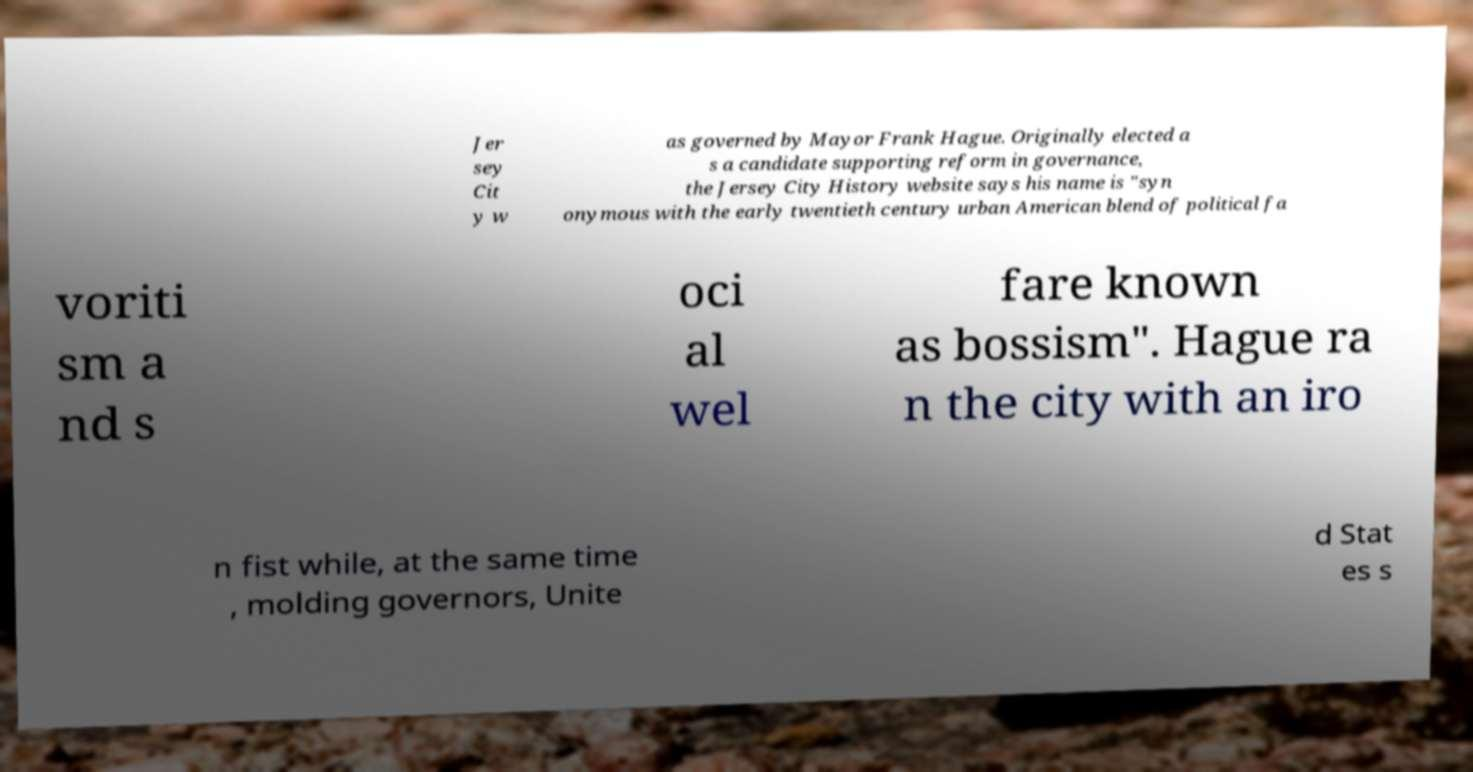Could you extract and type out the text from this image? Jer sey Cit y w as governed by Mayor Frank Hague. Originally elected a s a candidate supporting reform in governance, the Jersey City History website says his name is "syn onymous with the early twentieth century urban American blend of political fa voriti sm a nd s oci al wel fare known as bossism". Hague ra n the city with an iro n fist while, at the same time , molding governors, Unite d Stat es s 